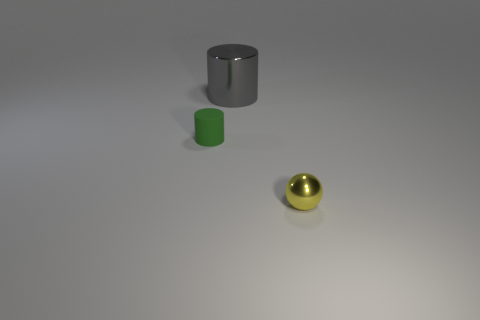The thing that is the same material as the tiny sphere is what shape?
Provide a succinct answer. Cylinder. What color is the other object that is the same size as the yellow thing?
Offer a very short reply. Green. Does the shiny thing left of the yellow metal sphere have the same size as the green object?
Make the answer very short. No. Does the metallic cylinder have the same color as the tiny rubber object?
Ensure brevity in your answer.  No. How many large green shiny blocks are there?
Your answer should be compact. 0. What number of cylinders are either yellow metallic things or big things?
Offer a terse response. 1. There is a small object that is in front of the tiny matte thing; how many small green matte objects are on the left side of it?
Your answer should be compact. 1. Do the small cylinder and the large cylinder have the same material?
Provide a short and direct response. No. Are there any big objects that have the same material as the tiny yellow ball?
Give a very brief answer. Yes. The tiny object behind the shiny object to the right of the shiny thing that is left of the tiny yellow metal sphere is what color?
Your answer should be compact. Green. 